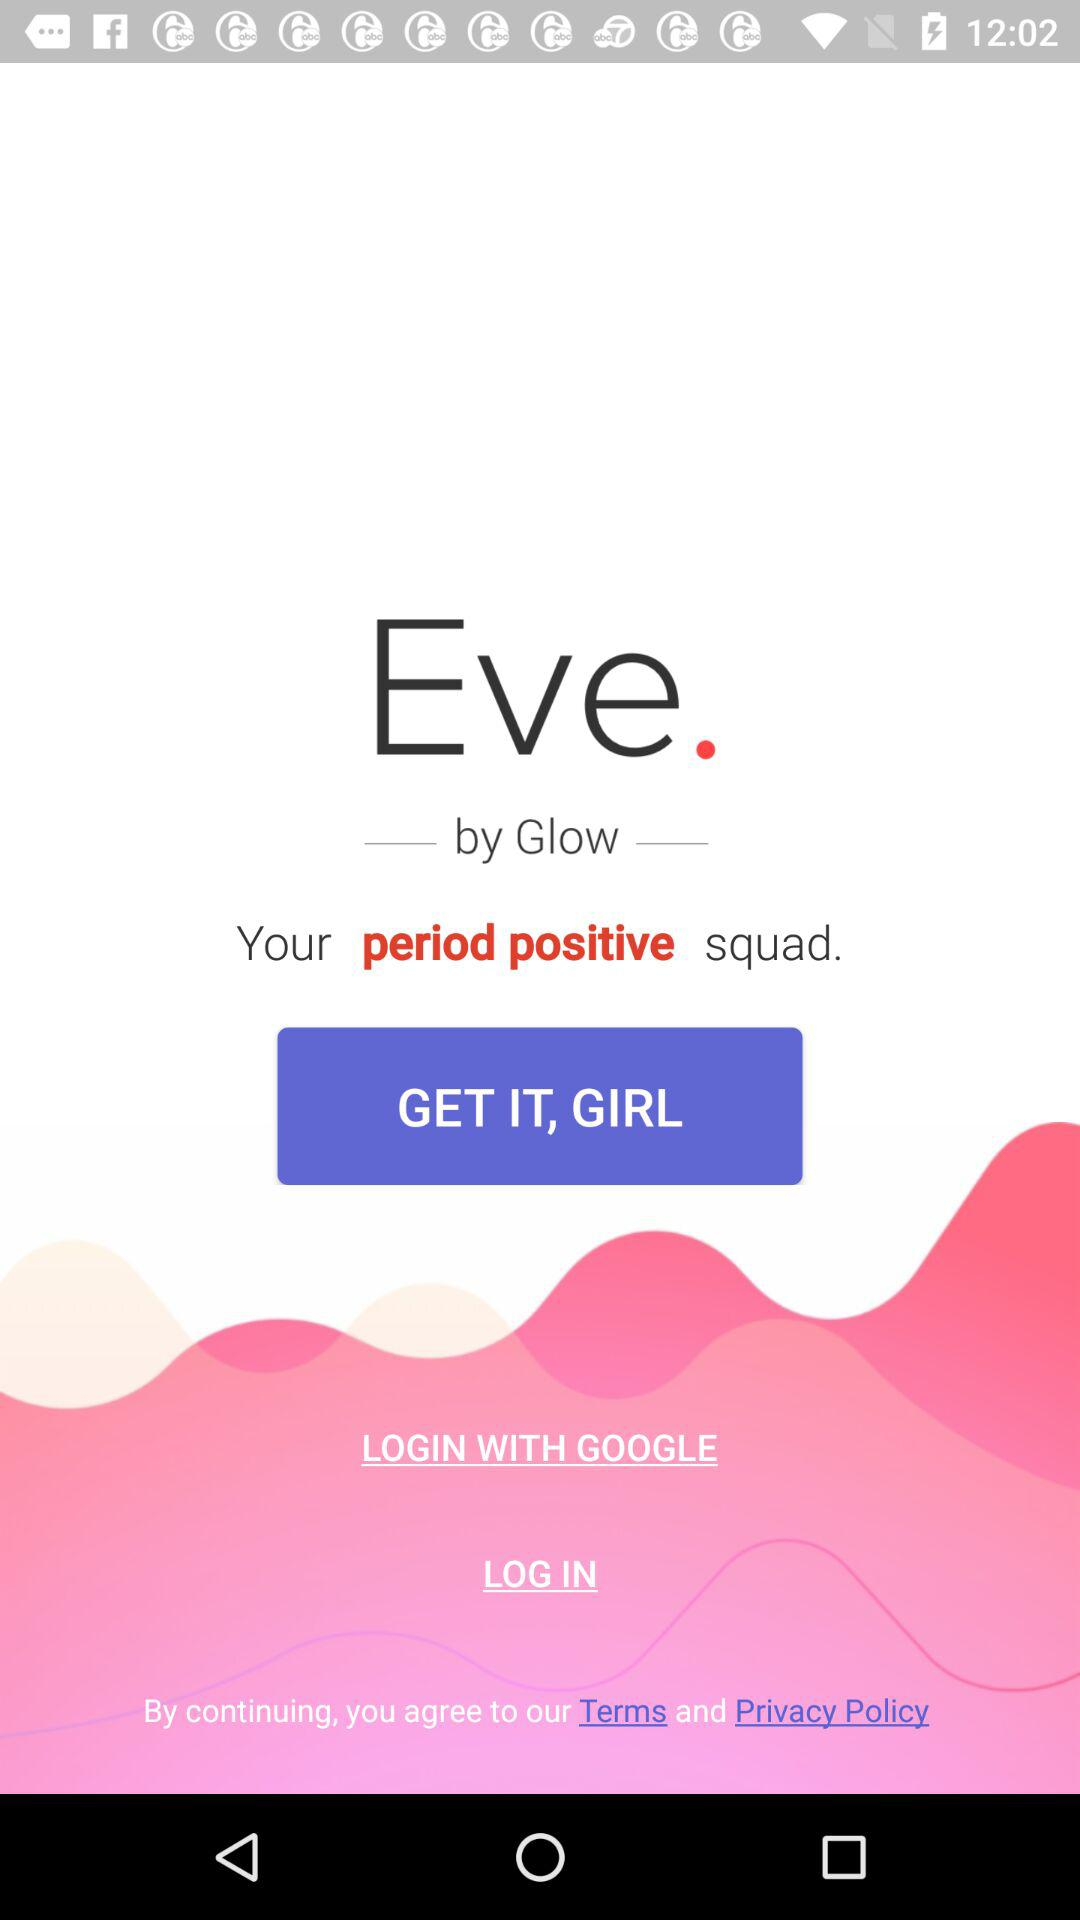What account can I use to log in? The account that you can use to log in is "GOOGLE". 